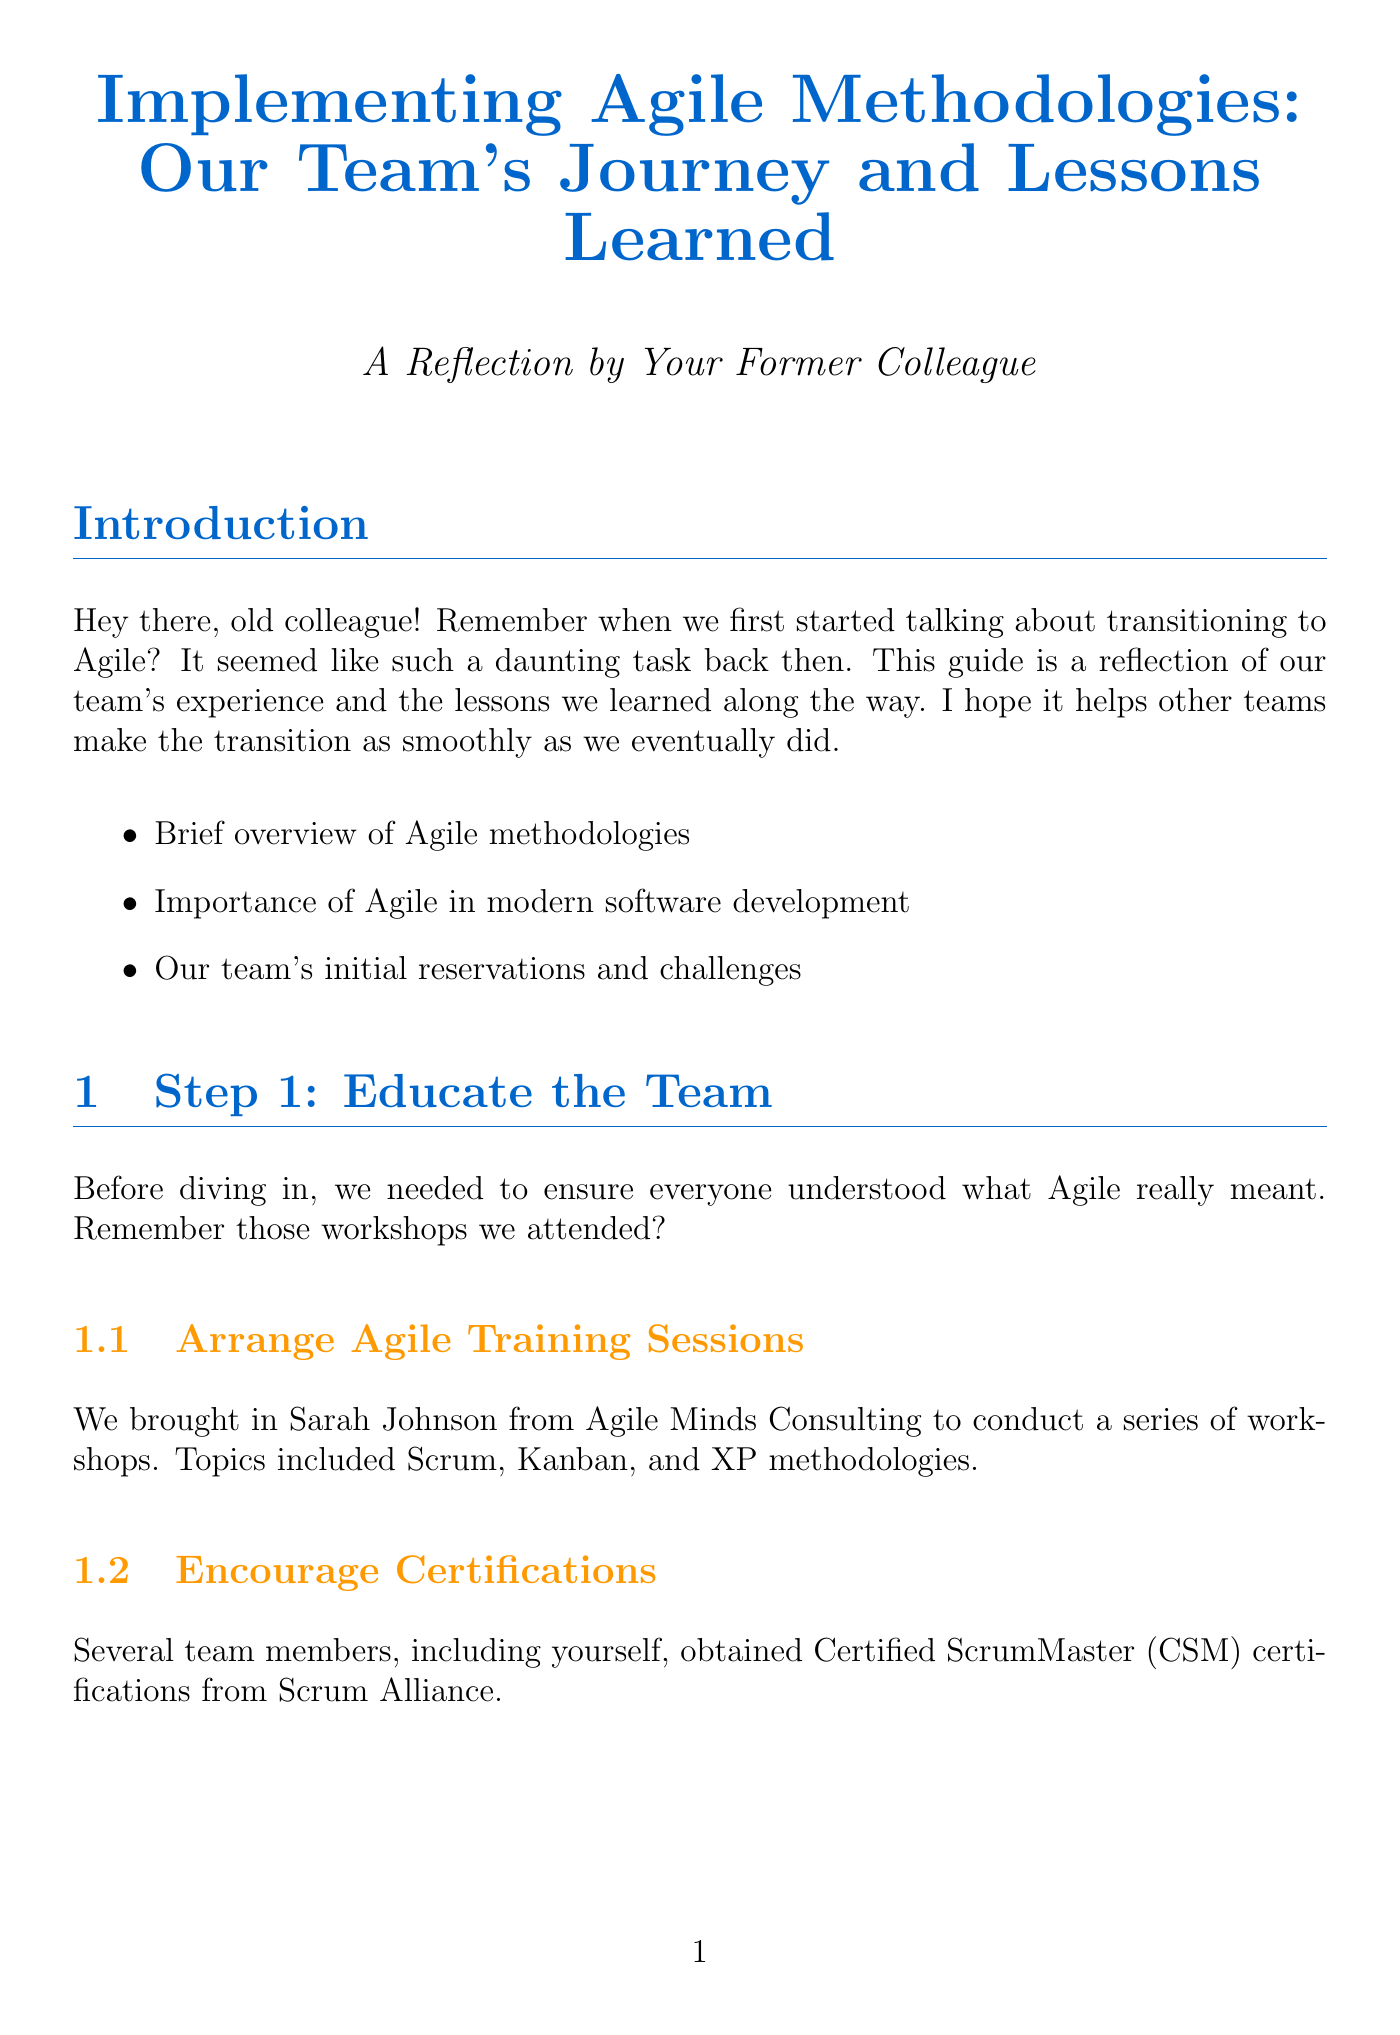what is the title of the document? The title is prominently displayed at the beginning of the document, reflecting the content focus on Agile methodologies.
Answer: Implementing Agile Methodologies: Our Team's Journey and Lessons Learned who conducted the Agile training sessions? The document states who was brought in for the workshops, clarifying the source of the training.
Answer: Sarah Johnson what Agile tool did the team select for project management? The document explicitly mentions the chosen tool for managing projects, highlighting this key decision.
Answer: Jira after how many weeks did the team begin their sprints? The document specifies the duration for the sprints, providing a clear timeline for their Agile practice.
Answer: 2 weeks which role was Lisa assigned in the Agile process? The document specifies the role that required persuasion for Lisa, reflecting the organizational structure.
Answer: Scrum Master what was the purpose of monthly team surveys? The document outlines the aim of these surveys, indicating a systematic approach to feedback.
Answer: Gauge satisfaction what are key takeaways from the Agile transition? The conclusion details the main lessons learned, which are summarized in a list of points.
Answer: Patience and persistence are crucial during the transition which Agile framework did the team ultimately choose? The document indicates the team's deliberation and final decision regarding the Agile approach.
Answer: Scrum 